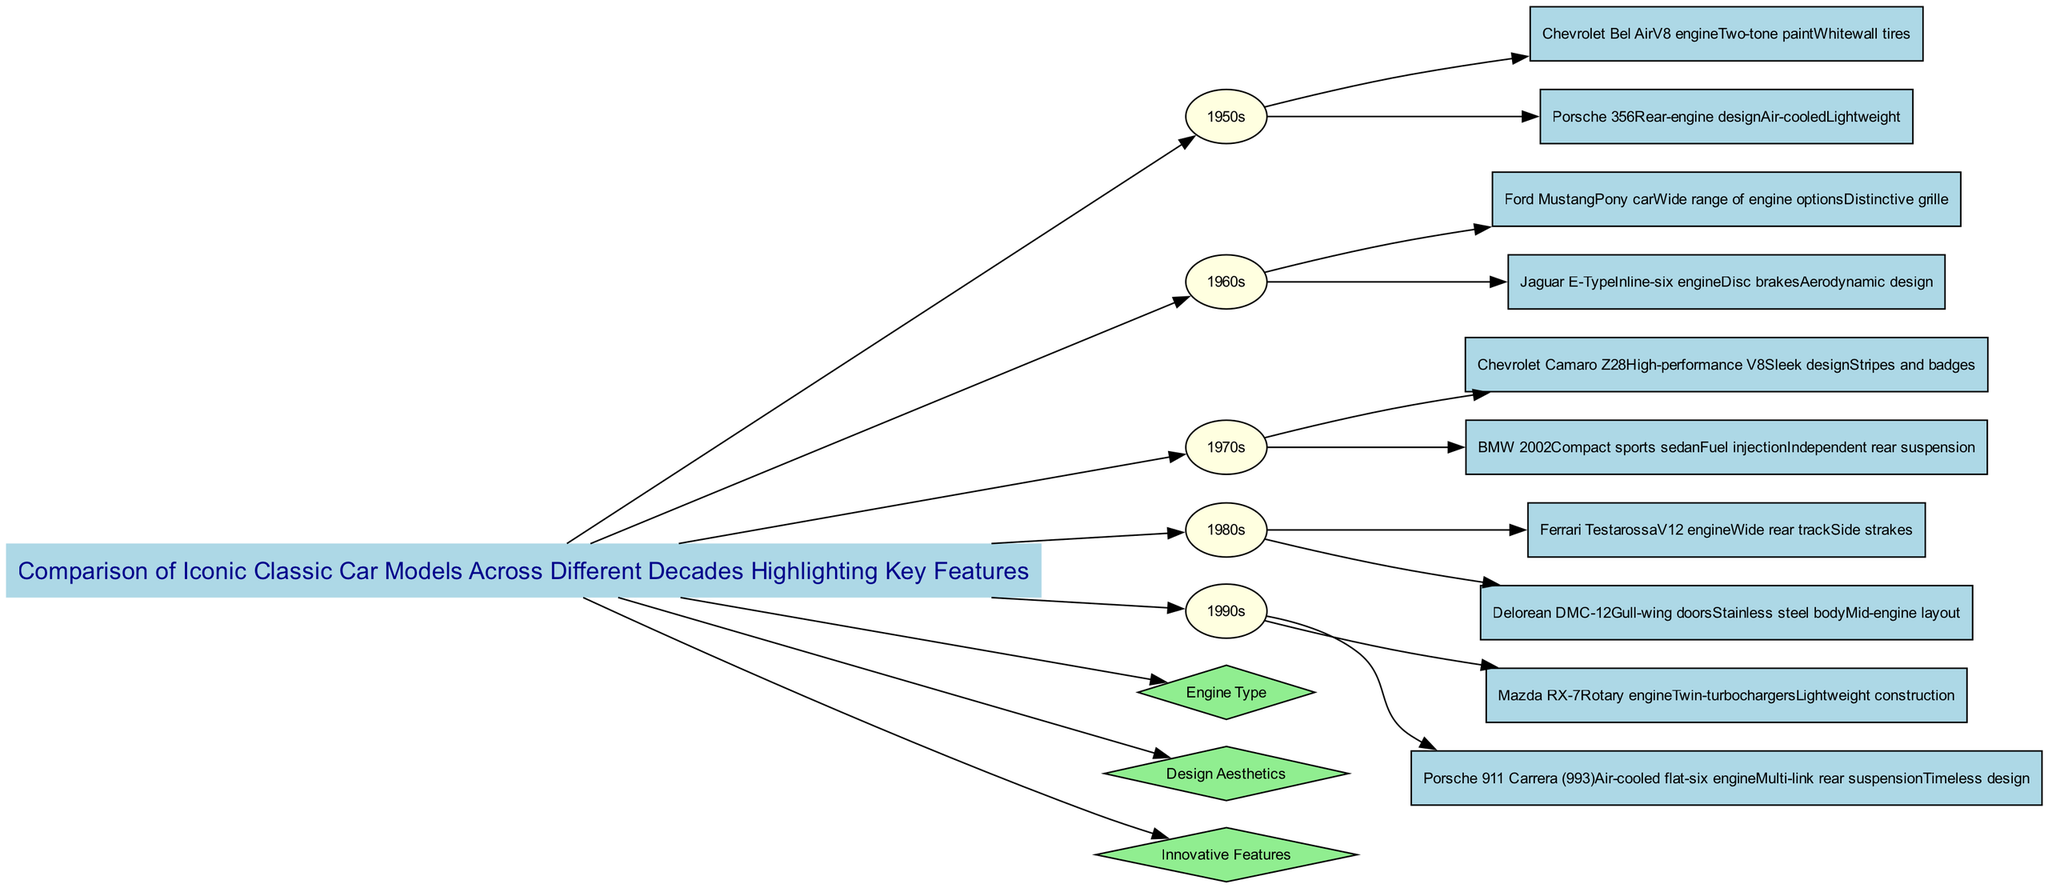What car models are compared in the 1960s? The diagram includes Ford Mustang and Jaguar E-Type as the car models from the 1960s. This is determined by looking at the specific decade node labeled "1960s" and noting the cars listed beneath it.
Answer: Ford Mustang, Jaguar E-Type How many decades are represented in the diagram? The diagram lists five decades: 1950s, 1960s, 1970s, 1980s, and 1990s. By counting the nodes that represent each decade, the total number is confirmed.
Answer: Five What is a key feature of the Chevrolet Bel Air? A key feature listed for the Chevrolet Bel Air is "V8 engine". This is found by locating the node for the Chevrolet Bel Air under the 1950s decade and reading its features.
Answer: V8 engine Which car model features gull-wing doors? The DeLorean DMC-12 is the model that features gull-wing doors. This is found by identifying the DeLorean DMC-12 node in the 1980s section and checking its key features.
Answer: DeLorean DMC-12 Which decade has the car model with a rotary engine? The 1990s decade includes the Mazda RX-7, which features a rotary engine. By examining the cars listed under the 1990s node, this feature is confirmed.
Answer: 1990s What comparison metric is focused on vehicle aesthetics? The comparison metric that addresses vehicle aesthetics is "Design Aesthetics". This can be seen as a separate metric node connected to the title, addressing a specific aspect of comparison.
Answer: Design Aesthetics Which two cars from the 1970s are highlighted in the diagram? The highlighted cars from the 1970s are Chevrolet Camaro Z28 and BMW 2002. This is determined by examining the node for the 1970s and identifying the cars listed there.
Answer: Chevrolet Camaro Z28, BMW 2002 What is a common feature shared by both the Porsche 356 and Porsche 911 Carrera (993)? Both models share the feature of being air-cooled. This requires pulling information from the features of each car model listed in the respective decade sections.
Answer: Air-cooled What key feature distinguishes the Ferrari Testarossa from other cars in the 1980s? The Ferrari Testarossa is distinguished by its "V12 engine". This can be confirmed by looking directly under the 1980s node at the Ferrari Testarossa's list of features.
Answer: V12 engine 